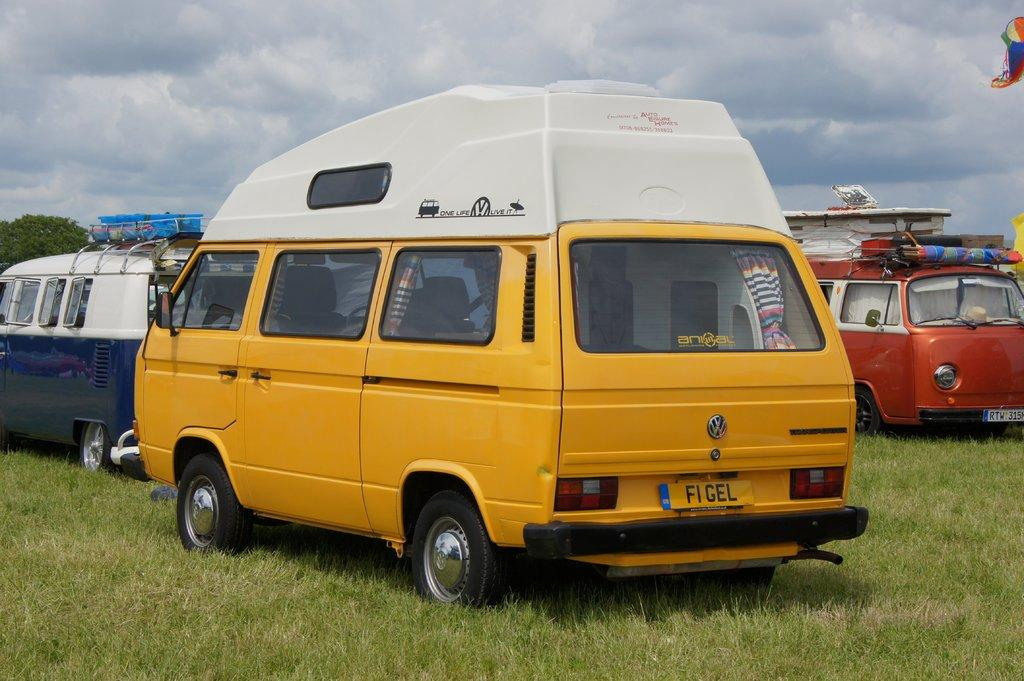What types of objects are on the ground in the image? There are vehicles on the ground in the image. What can be seen in the distance behind the vehicles? Trees are visible in the background of the image. What else is visible in the background of the image? The sky is visible in the background of the image. What type of caption is written on the vehicles in the image? There is no caption visible on the vehicles in the image. What type of vacation is being taken by the people in the vehicles? There is no indication of a vacation or people in the vehicles in the image. 